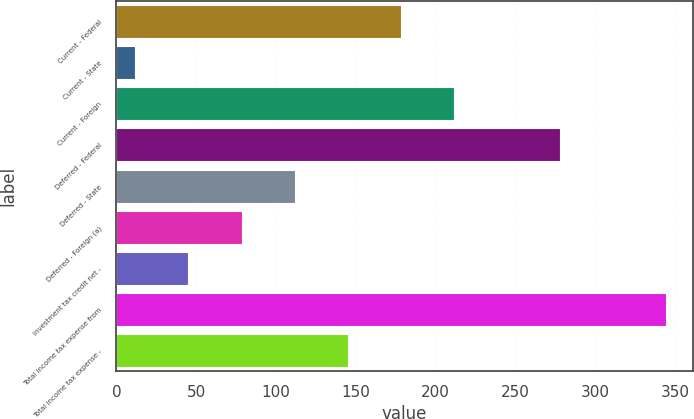Convert chart. <chart><loc_0><loc_0><loc_500><loc_500><bar_chart><fcel>Current - Federal<fcel>Current - State<fcel>Current - Foreign<fcel>Deferred - Federal<fcel>Deferred - State<fcel>Deferred - Foreign (a)<fcel>Investment tax credit net -<fcel>Total income tax expense from<fcel>Total income tax expense -<nl><fcel>178<fcel>12<fcel>211.2<fcel>277.6<fcel>111.6<fcel>78.4<fcel>45.2<fcel>344<fcel>144.8<nl></chart> 